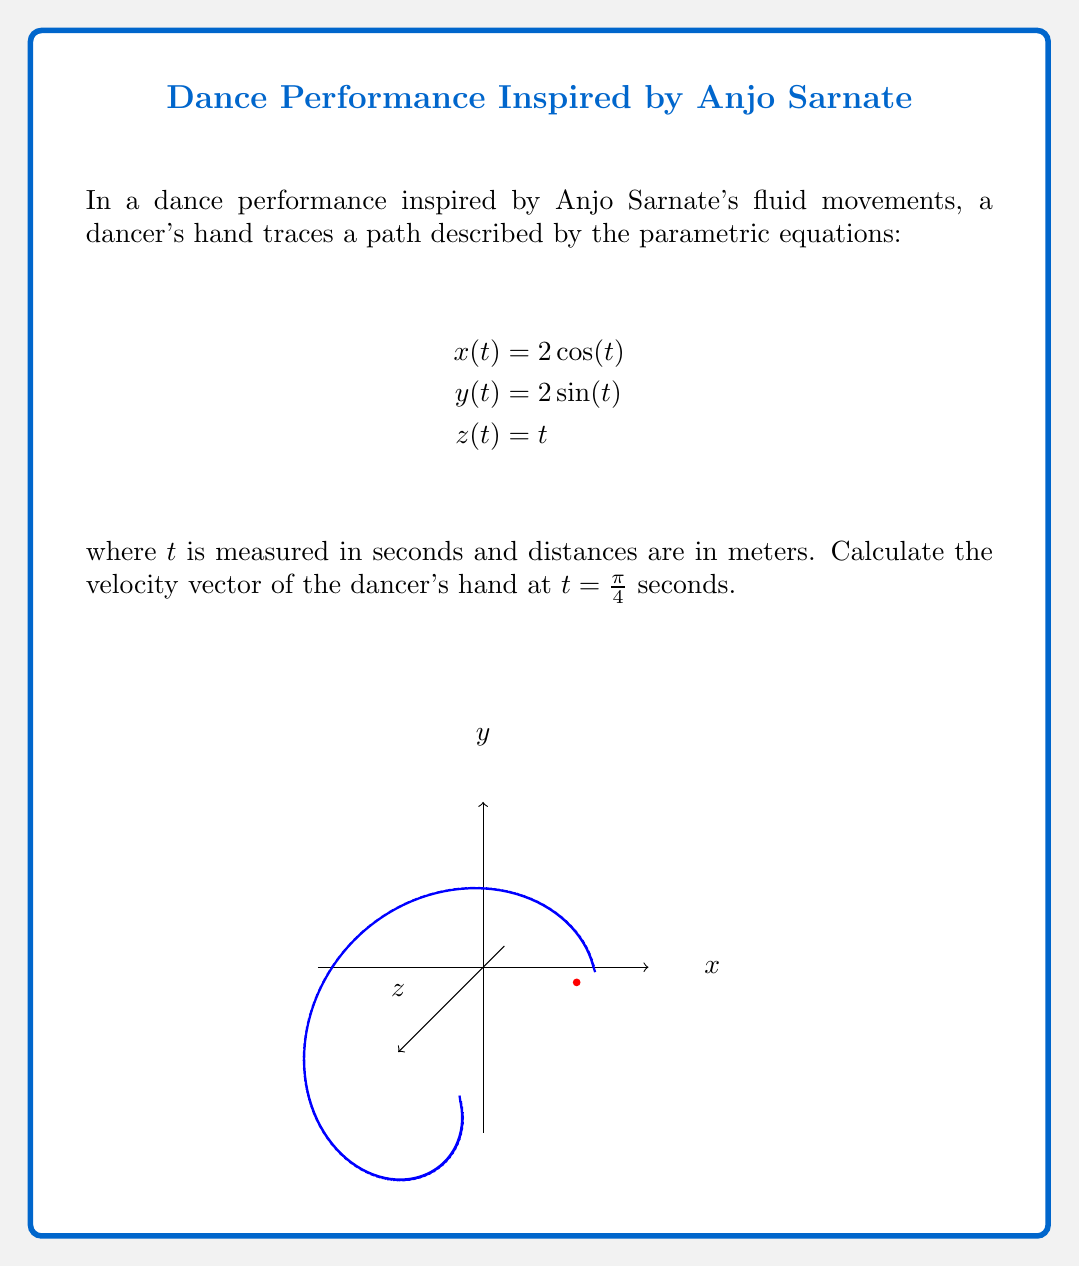Show me your answer to this math problem. To find the velocity vector, we need to differentiate each component of the position vector with respect to time:

1) First, let's find the velocity components:
   $$v_x(t) = \frac{dx}{dt} = -2\sin(t)$$
   $$v_y(t) = \frac{dy}{dt} = 2\cos(t)$$
   $$v_z(t) = \frac{dz}{dt} = 1$$

2) The velocity vector is given by:
   $$\vec{v}(t) = \langle v_x(t), v_y(t), v_z(t) \rangle = \langle -2\sin(t), 2\cos(t), 1 \rangle$$

3) We need to evaluate this at $t = \frac{\pi}{4}$:
   $$\vec{v}(\frac{\pi}{4}) = \langle -2\sin(\frac{\pi}{4}), 2\cos(\frac{\pi}{4}), 1 \rangle$$

4) Recall that $\sin(\frac{\pi}{4}) = \cos(\frac{\pi}{4}) = \frac{\sqrt{2}}{2}$:
   $$\vec{v}(\frac{\pi}{4}) = \langle -2(\frac{\sqrt{2}}{2}), 2(\frac{\sqrt{2}}{2}), 1 \rangle$$

5) Simplify:
   $$\vec{v}(\frac{\pi}{4}) = \langle -\sqrt{2}, \sqrt{2}, 1 \rangle$$

This vector represents the instantaneous velocity of the dancer's hand at $t = \frac{\pi}{4}$ seconds.
Answer: $\langle -\sqrt{2}, \sqrt{2}, 1 \rangle$ m/s 